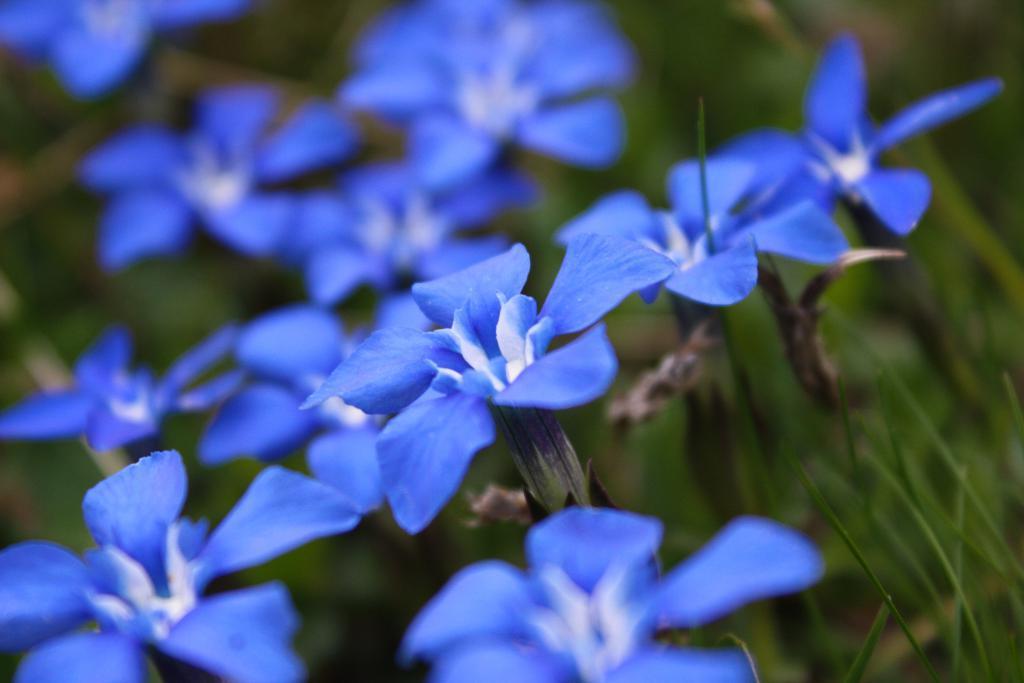Could you give a brief overview of what you see in this image? In this image we can see purple colored flowers, plants, also the background is blurred. 